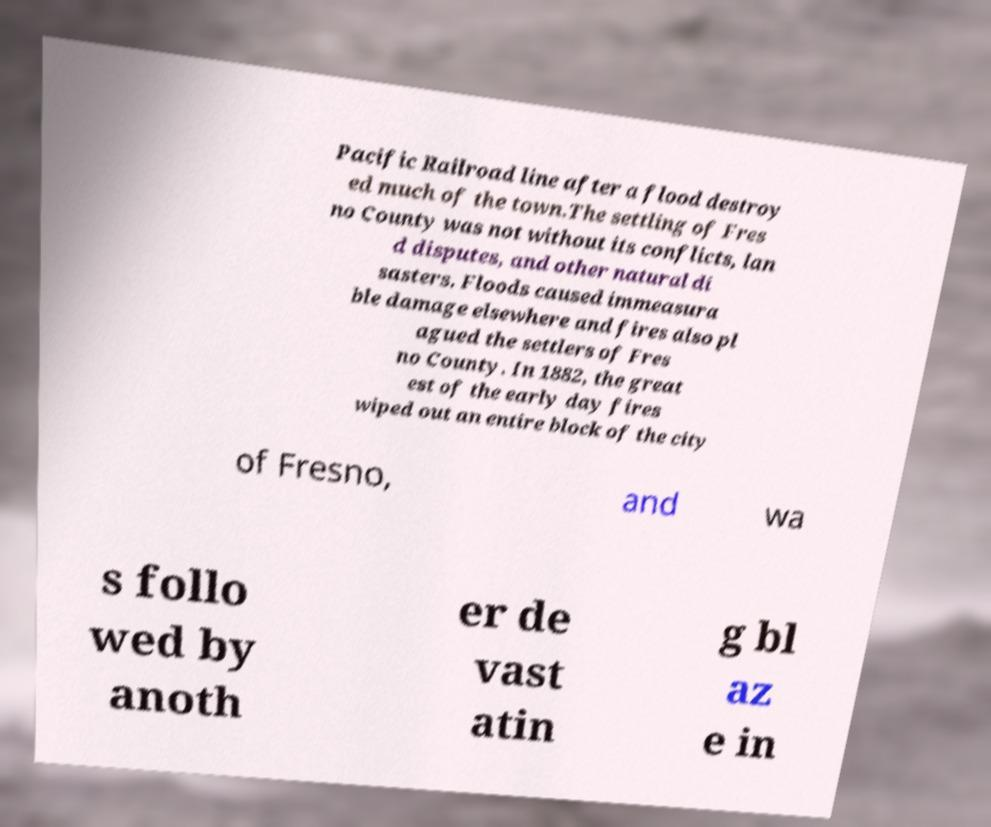Please read and relay the text visible in this image. What does it say? Pacific Railroad line after a flood destroy ed much of the town.The settling of Fres no County was not without its conflicts, lan d disputes, and other natural di sasters. Floods caused immeasura ble damage elsewhere and fires also pl agued the settlers of Fres no County. In 1882, the great est of the early day fires wiped out an entire block of the city of Fresno, and wa s follo wed by anoth er de vast atin g bl az e in 